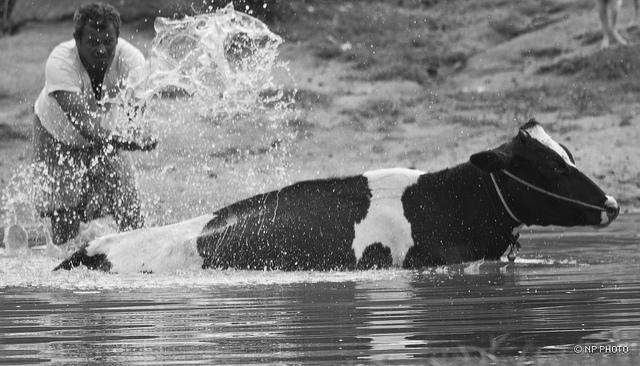What is the man doing to the cow?
Answer briefly. Splashing. Is the cow moving?
Be succinct. Yes. Does the cow have a harness around it's head?
Write a very short answer. Yes. 